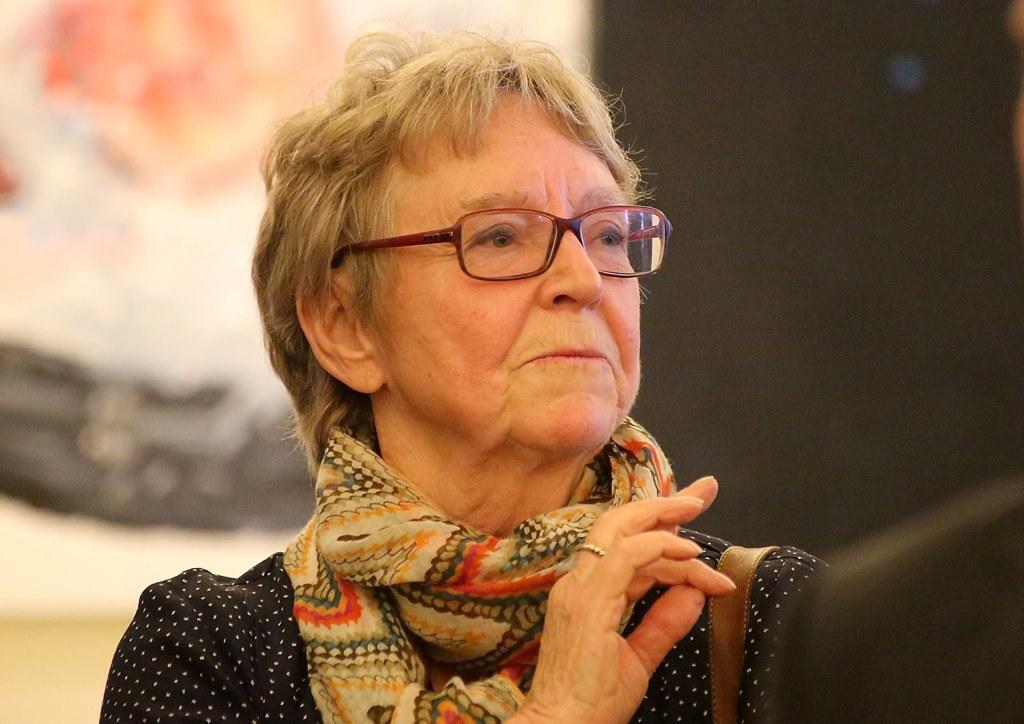In one or two sentences, can you explain what this image depicts? In this image in front there is a person and the background of the image is blur. 